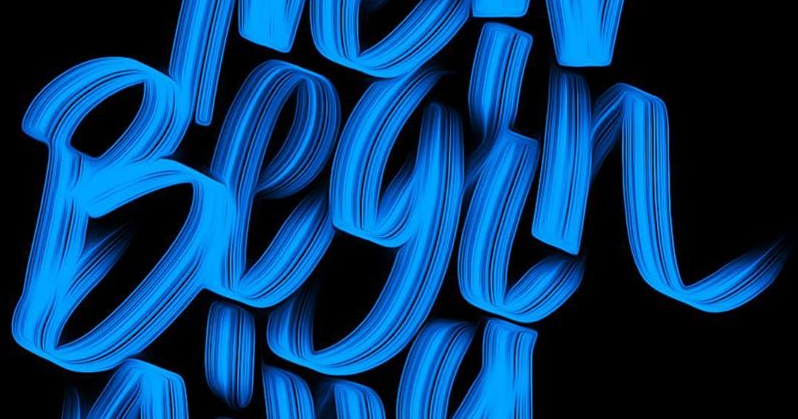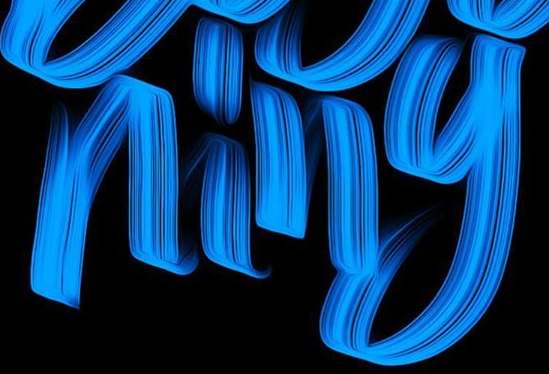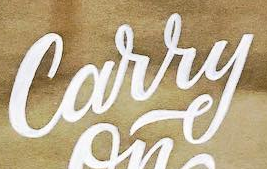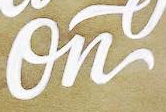What words are shown in these images in order, separated by a semicolon? Begin; ning; Carry; On 